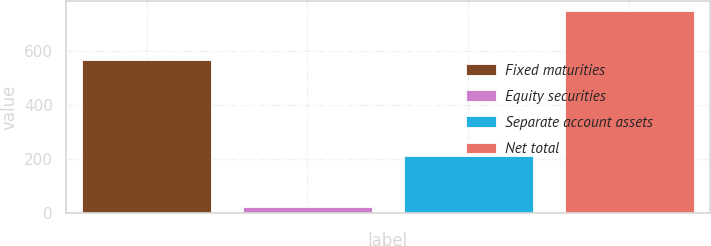<chart> <loc_0><loc_0><loc_500><loc_500><bar_chart><fcel>Fixed maturities<fcel>Equity securities<fcel>Separate account assets<fcel>Net total<nl><fcel>567.2<fcel>20.7<fcel>209.5<fcel>747<nl></chart> 